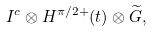Convert formula to latex. <formula><loc_0><loc_0><loc_500><loc_500>I ^ { c } \otimes H ^ { \pi / 2 + } ( t ) \otimes \widetilde { G } ,</formula> 